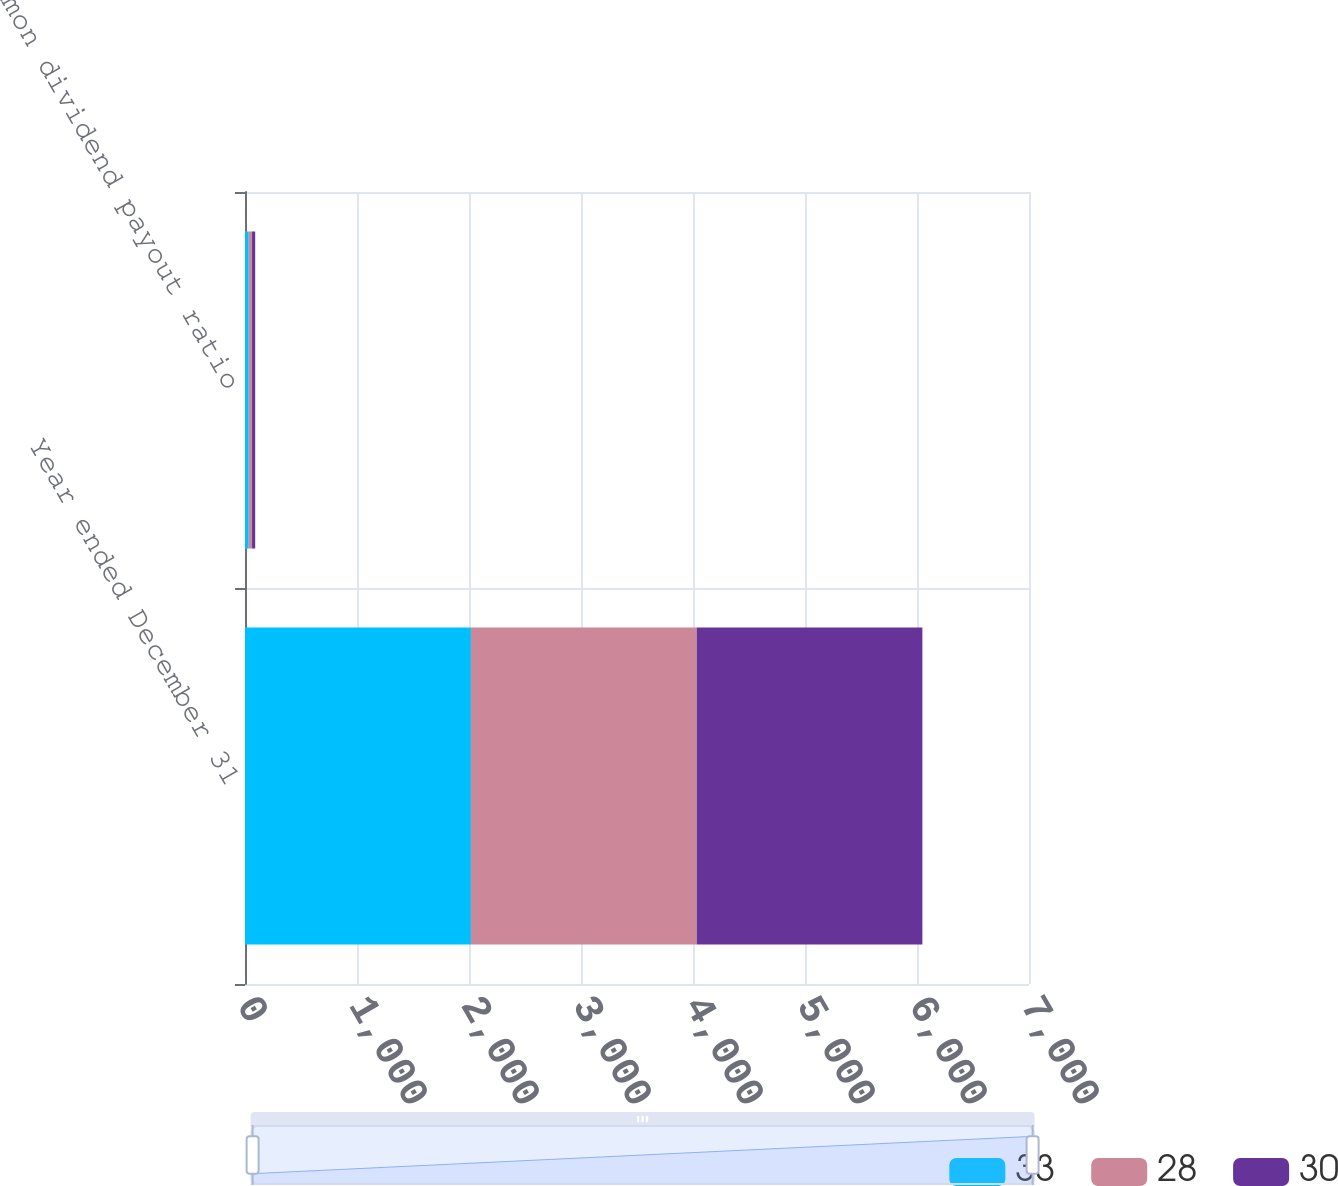<chart> <loc_0><loc_0><loc_500><loc_500><stacked_bar_chart><ecel><fcel>Year ended December 31<fcel>Common dividend payout ratio<nl><fcel>33<fcel>2017<fcel>33<nl><fcel>28<fcel>2016<fcel>30<nl><fcel>30<fcel>2015<fcel>28<nl></chart> 